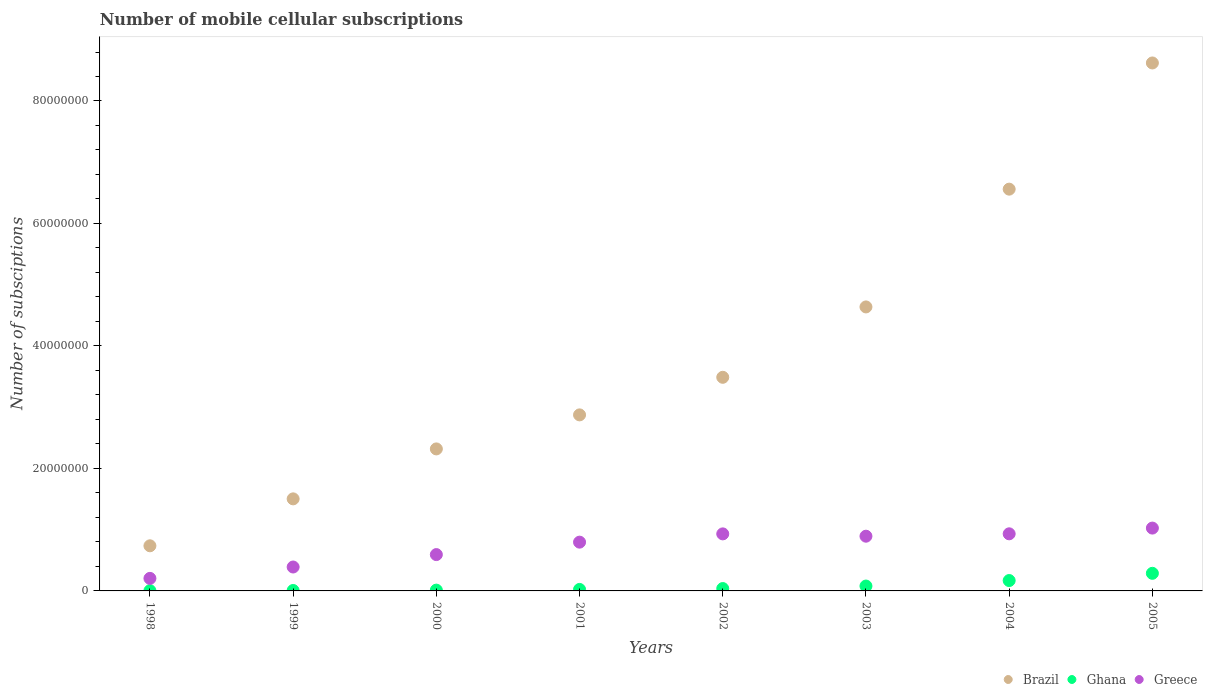Is the number of dotlines equal to the number of legend labels?
Provide a succinct answer. Yes. What is the number of mobile cellular subscriptions in Brazil in 1998?
Ensure brevity in your answer.  7.37e+06. Across all years, what is the maximum number of mobile cellular subscriptions in Brazil?
Your answer should be very brief. 8.62e+07. Across all years, what is the minimum number of mobile cellular subscriptions in Greece?
Your answer should be very brief. 2.05e+06. In which year was the number of mobile cellular subscriptions in Ghana maximum?
Offer a terse response. 2005. What is the total number of mobile cellular subscriptions in Greece in the graph?
Make the answer very short. 5.77e+07. What is the difference between the number of mobile cellular subscriptions in Ghana in 2002 and that in 2003?
Your response must be concise. -4.09e+05. What is the difference between the number of mobile cellular subscriptions in Greece in 2004 and the number of mobile cellular subscriptions in Brazil in 2002?
Your answer should be very brief. -2.56e+07. What is the average number of mobile cellular subscriptions in Brazil per year?
Ensure brevity in your answer.  3.84e+07. In the year 2001, what is the difference between the number of mobile cellular subscriptions in Ghana and number of mobile cellular subscriptions in Greece?
Your answer should be very brief. -7.72e+06. What is the ratio of the number of mobile cellular subscriptions in Ghana in 1999 to that in 2000?
Make the answer very short. 0.54. What is the difference between the highest and the second highest number of mobile cellular subscriptions in Ghana?
Ensure brevity in your answer.  1.18e+06. What is the difference between the highest and the lowest number of mobile cellular subscriptions in Brazil?
Keep it short and to the point. 7.88e+07. In how many years, is the number of mobile cellular subscriptions in Brazil greater than the average number of mobile cellular subscriptions in Brazil taken over all years?
Make the answer very short. 3. Is it the case that in every year, the sum of the number of mobile cellular subscriptions in Greece and number of mobile cellular subscriptions in Ghana  is greater than the number of mobile cellular subscriptions in Brazil?
Give a very brief answer. No. How many dotlines are there?
Make the answer very short. 3. How many years are there in the graph?
Provide a short and direct response. 8. What is the difference between two consecutive major ticks on the Y-axis?
Give a very brief answer. 2.00e+07. Are the values on the major ticks of Y-axis written in scientific E-notation?
Provide a short and direct response. No. Does the graph contain any zero values?
Your answer should be very brief. No. Where does the legend appear in the graph?
Offer a terse response. Bottom right. How many legend labels are there?
Keep it short and to the point. 3. How are the legend labels stacked?
Make the answer very short. Horizontal. What is the title of the graph?
Offer a terse response. Number of mobile cellular subscriptions. Does "Bulgaria" appear as one of the legend labels in the graph?
Offer a terse response. No. What is the label or title of the X-axis?
Offer a very short reply. Years. What is the label or title of the Y-axis?
Give a very brief answer. Number of subsciptions. What is the Number of subsciptions of Brazil in 1998?
Ensure brevity in your answer.  7.37e+06. What is the Number of subsciptions of Ghana in 1998?
Your response must be concise. 4.18e+04. What is the Number of subsciptions of Greece in 1998?
Your answer should be compact. 2.05e+06. What is the Number of subsciptions of Brazil in 1999?
Give a very brief answer. 1.50e+07. What is the Number of subsciptions in Ghana in 1999?
Your response must be concise. 7.00e+04. What is the Number of subsciptions in Greece in 1999?
Offer a very short reply. 3.90e+06. What is the Number of subsciptions in Brazil in 2000?
Provide a short and direct response. 2.32e+07. What is the Number of subsciptions in Ghana in 2000?
Offer a very short reply. 1.30e+05. What is the Number of subsciptions of Greece in 2000?
Make the answer very short. 5.93e+06. What is the Number of subsciptions in Brazil in 2001?
Your answer should be compact. 2.87e+07. What is the Number of subsciptions of Ghana in 2001?
Your answer should be compact. 2.44e+05. What is the Number of subsciptions in Greece in 2001?
Make the answer very short. 7.96e+06. What is the Number of subsciptions in Brazil in 2002?
Your answer should be compact. 3.49e+07. What is the Number of subsciptions of Ghana in 2002?
Your answer should be compact. 3.87e+05. What is the Number of subsciptions of Greece in 2002?
Provide a succinct answer. 9.31e+06. What is the Number of subsciptions of Brazil in 2003?
Your answer should be very brief. 4.64e+07. What is the Number of subsciptions in Ghana in 2003?
Give a very brief answer. 7.96e+05. What is the Number of subsciptions in Greece in 2003?
Make the answer very short. 8.94e+06. What is the Number of subsciptions in Brazil in 2004?
Give a very brief answer. 6.56e+07. What is the Number of subsciptions of Ghana in 2004?
Keep it short and to the point. 1.70e+06. What is the Number of subsciptions in Greece in 2004?
Make the answer very short. 9.32e+06. What is the Number of subsciptions of Brazil in 2005?
Keep it short and to the point. 8.62e+07. What is the Number of subsciptions of Ghana in 2005?
Give a very brief answer. 2.87e+06. What is the Number of subsciptions of Greece in 2005?
Keep it short and to the point. 1.03e+07. Across all years, what is the maximum Number of subsciptions in Brazil?
Your answer should be very brief. 8.62e+07. Across all years, what is the maximum Number of subsciptions in Ghana?
Your answer should be compact. 2.87e+06. Across all years, what is the maximum Number of subsciptions in Greece?
Make the answer very short. 1.03e+07. Across all years, what is the minimum Number of subsciptions of Brazil?
Your response must be concise. 7.37e+06. Across all years, what is the minimum Number of subsciptions in Ghana?
Keep it short and to the point. 4.18e+04. Across all years, what is the minimum Number of subsciptions of Greece?
Give a very brief answer. 2.05e+06. What is the total Number of subsciptions of Brazil in the graph?
Ensure brevity in your answer.  3.07e+08. What is the total Number of subsciptions in Ghana in the graph?
Your answer should be compact. 6.24e+06. What is the total Number of subsciptions of Greece in the graph?
Your answer should be very brief. 5.77e+07. What is the difference between the Number of subsciptions in Brazil in 1998 and that in 1999?
Keep it short and to the point. -7.66e+06. What is the difference between the Number of subsciptions of Ghana in 1998 and that in 1999?
Offer a terse response. -2.83e+04. What is the difference between the Number of subsciptions in Greece in 1998 and that in 1999?
Provide a succinct answer. -1.86e+06. What is the difference between the Number of subsciptions in Brazil in 1998 and that in 2000?
Ensure brevity in your answer.  -1.58e+07. What is the difference between the Number of subsciptions in Ghana in 1998 and that in 2000?
Keep it short and to the point. -8.83e+04. What is the difference between the Number of subsciptions in Greece in 1998 and that in 2000?
Your response must be concise. -3.89e+06. What is the difference between the Number of subsciptions in Brazil in 1998 and that in 2001?
Your response must be concise. -2.14e+07. What is the difference between the Number of subsciptions of Ghana in 1998 and that in 2001?
Offer a terse response. -2.02e+05. What is the difference between the Number of subsciptions in Greece in 1998 and that in 2001?
Your answer should be very brief. -5.92e+06. What is the difference between the Number of subsciptions in Brazil in 1998 and that in 2002?
Your response must be concise. -2.75e+07. What is the difference between the Number of subsciptions of Ghana in 1998 and that in 2002?
Your answer should be compact. -3.45e+05. What is the difference between the Number of subsciptions in Greece in 1998 and that in 2002?
Give a very brief answer. -7.27e+06. What is the difference between the Number of subsciptions in Brazil in 1998 and that in 2003?
Provide a succinct answer. -3.90e+07. What is the difference between the Number of subsciptions in Ghana in 1998 and that in 2003?
Offer a very short reply. -7.54e+05. What is the difference between the Number of subsciptions of Greece in 1998 and that in 2003?
Keep it short and to the point. -6.89e+06. What is the difference between the Number of subsciptions of Brazil in 1998 and that in 2004?
Provide a short and direct response. -5.82e+07. What is the difference between the Number of subsciptions in Ghana in 1998 and that in 2004?
Your answer should be very brief. -1.65e+06. What is the difference between the Number of subsciptions in Greece in 1998 and that in 2004?
Make the answer very short. -7.28e+06. What is the difference between the Number of subsciptions of Brazil in 1998 and that in 2005?
Make the answer very short. -7.88e+07. What is the difference between the Number of subsciptions of Ghana in 1998 and that in 2005?
Your answer should be very brief. -2.83e+06. What is the difference between the Number of subsciptions of Greece in 1998 and that in 2005?
Provide a succinct answer. -8.21e+06. What is the difference between the Number of subsciptions of Brazil in 1999 and that in 2000?
Ensure brevity in your answer.  -8.16e+06. What is the difference between the Number of subsciptions in Ghana in 1999 and that in 2000?
Provide a succinct answer. -6.00e+04. What is the difference between the Number of subsciptions of Greece in 1999 and that in 2000?
Ensure brevity in your answer.  -2.03e+06. What is the difference between the Number of subsciptions in Brazil in 1999 and that in 2001?
Your answer should be very brief. -1.37e+07. What is the difference between the Number of subsciptions in Ghana in 1999 and that in 2001?
Give a very brief answer. -1.74e+05. What is the difference between the Number of subsciptions in Greece in 1999 and that in 2001?
Make the answer very short. -4.06e+06. What is the difference between the Number of subsciptions of Brazil in 1999 and that in 2002?
Provide a succinct answer. -1.98e+07. What is the difference between the Number of subsciptions in Ghana in 1999 and that in 2002?
Your answer should be compact. -3.17e+05. What is the difference between the Number of subsciptions of Greece in 1999 and that in 2002?
Give a very brief answer. -5.41e+06. What is the difference between the Number of subsciptions of Brazil in 1999 and that in 2003?
Offer a very short reply. -3.13e+07. What is the difference between the Number of subsciptions of Ghana in 1999 and that in 2003?
Offer a very short reply. -7.26e+05. What is the difference between the Number of subsciptions in Greece in 1999 and that in 2003?
Give a very brief answer. -5.03e+06. What is the difference between the Number of subsciptions in Brazil in 1999 and that in 2004?
Your response must be concise. -5.06e+07. What is the difference between the Number of subsciptions of Ghana in 1999 and that in 2004?
Offer a very short reply. -1.62e+06. What is the difference between the Number of subsciptions in Greece in 1999 and that in 2004?
Provide a short and direct response. -5.42e+06. What is the difference between the Number of subsciptions in Brazil in 1999 and that in 2005?
Your answer should be compact. -7.12e+07. What is the difference between the Number of subsciptions of Ghana in 1999 and that in 2005?
Provide a short and direct response. -2.80e+06. What is the difference between the Number of subsciptions of Greece in 1999 and that in 2005?
Keep it short and to the point. -6.36e+06. What is the difference between the Number of subsciptions in Brazil in 2000 and that in 2001?
Ensure brevity in your answer.  -5.56e+06. What is the difference between the Number of subsciptions of Ghana in 2000 and that in 2001?
Ensure brevity in your answer.  -1.14e+05. What is the difference between the Number of subsciptions of Greece in 2000 and that in 2001?
Give a very brief answer. -2.03e+06. What is the difference between the Number of subsciptions in Brazil in 2000 and that in 2002?
Your answer should be compact. -1.17e+07. What is the difference between the Number of subsciptions of Ghana in 2000 and that in 2002?
Your response must be concise. -2.57e+05. What is the difference between the Number of subsciptions in Greece in 2000 and that in 2002?
Make the answer very short. -3.38e+06. What is the difference between the Number of subsciptions of Brazil in 2000 and that in 2003?
Give a very brief answer. -2.32e+07. What is the difference between the Number of subsciptions in Ghana in 2000 and that in 2003?
Provide a succinct answer. -6.65e+05. What is the difference between the Number of subsciptions of Greece in 2000 and that in 2003?
Make the answer very short. -3.00e+06. What is the difference between the Number of subsciptions of Brazil in 2000 and that in 2004?
Your answer should be compact. -4.24e+07. What is the difference between the Number of subsciptions of Ghana in 2000 and that in 2004?
Provide a succinct answer. -1.56e+06. What is the difference between the Number of subsciptions in Greece in 2000 and that in 2004?
Make the answer very short. -3.39e+06. What is the difference between the Number of subsciptions of Brazil in 2000 and that in 2005?
Provide a short and direct response. -6.30e+07. What is the difference between the Number of subsciptions of Ghana in 2000 and that in 2005?
Provide a succinct answer. -2.74e+06. What is the difference between the Number of subsciptions in Greece in 2000 and that in 2005?
Make the answer very short. -4.33e+06. What is the difference between the Number of subsciptions of Brazil in 2001 and that in 2002?
Provide a succinct answer. -6.14e+06. What is the difference between the Number of subsciptions of Ghana in 2001 and that in 2002?
Offer a very short reply. -1.43e+05. What is the difference between the Number of subsciptions in Greece in 2001 and that in 2002?
Provide a succinct answer. -1.35e+06. What is the difference between the Number of subsciptions of Brazil in 2001 and that in 2003?
Ensure brevity in your answer.  -1.76e+07. What is the difference between the Number of subsciptions of Ghana in 2001 and that in 2003?
Ensure brevity in your answer.  -5.52e+05. What is the difference between the Number of subsciptions in Greece in 2001 and that in 2003?
Give a very brief answer. -9.72e+05. What is the difference between the Number of subsciptions in Brazil in 2001 and that in 2004?
Give a very brief answer. -3.69e+07. What is the difference between the Number of subsciptions in Ghana in 2001 and that in 2004?
Provide a short and direct response. -1.45e+06. What is the difference between the Number of subsciptions in Greece in 2001 and that in 2004?
Your response must be concise. -1.36e+06. What is the difference between the Number of subsciptions of Brazil in 2001 and that in 2005?
Give a very brief answer. -5.75e+07. What is the difference between the Number of subsciptions in Ghana in 2001 and that in 2005?
Offer a very short reply. -2.63e+06. What is the difference between the Number of subsciptions of Greece in 2001 and that in 2005?
Your answer should be compact. -2.30e+06. What is the difference between the Number of subsciptions in Brazil in 2002 and that in 2003?
Make the answer very short. -1.15e+07. What is the difference between the Number of subsciptions of Ghana in 2002 and that in 2003?
Give a very brief answer. -4.09e+05. What is the difference between the Number of subsciptions of Greece in 2002 and that in 2003?
Make the answer very short. 3.78e+05. What is the difference between the Number of subsciptions in Brazil in 2002 and that in 2004?
Your response must be concise. -3.07e+07. What is the difference between the Number of subsciptions in Ghana in 2002 and that in 2004?
Offer a very short reply. -1.31e+06. What is the difference between the Number of subsciptions of Greece in 2002 and that in 2004?
Offer a terse response. -1.01e+04. What is the difference between the Number of subsciptions of Brazil in 2002 and that in 2005?
Provide a short and direct response. -5.13e+07. What is the difference between the Number of subsciptions of Ghana in 2002 and that in 2005?
Make the answer very short. -2.49e+06. What is the difference between the Number of subsciptions in Greece in 2002 and that in 2005?
Provide a short and direct response. -9.46e+05. What is the difference between the Number of subsciptions of Brazil in 2003 and that in 2004?
Make the answer very short. -1.92e+07. What is the difference between the Number of subsciptions in Ghana in 2003 and that in 2004?
Keep it short and to the point. -8.99e+05. What is the difference between the Number of subsciptions in Greece in 2003 and that in 2004?
Your answer should be compact. -3.88e+05. What is the difference between the Number of subsciptions in Brazil in 2003 and that in 2005?
Offer a very short reply. -3.98e+07. What is the difference between the Number of subsciptions of Ghana in 2003 and that in 2005?
Your answer should be compact. -2.08e+06. What is the difference between the Number of subsciptions of Greece in 2003 and that in 2005?
Provide a succinct answer. -1.32e+06. What is the difference between the Number of subsciptions of Brazil in 2004 and that in 2005?
Provide a succinct answer. -2.06e+07. What is the difference between the Number of subsciptions of Ghana in 2004 and that in 2005?
Keep it short and to the point. -1.18e+06. What is the difference between the Number of subsciptions of Greece in 2004 and that in 2005?
Your response must be concise. -9.36e+05. What is the difference between the Number of subsciptions in Brazil in 1998 and the Number of subsciptions in Ghana in 1999?
Give a very brief answer. 7.30e+06. What is the difference between the Number of subsciptions in Brazil in 1998 and the Number of subsciptions in Greece in 1999?
Your answer should be very brief. 3.46e+06. What is the difference between the Number of subsciptions of Ghana in 1998 and the Number of subsciptions of Greece in 1999?
Your answer should be compact. -3.86e+06. What is the difference between the Number of subsciptions in Brazil in 1998 and the Number of subsciptions in Ghana in 2000?
Make the answer very short. 7.24e+06. What is the difference between the Number of subsciptions in Brazil in 1998 and the Number of subsciptions in Greece in 2000?
Keep it short and to the point. 1.44e+06. What is the difference between the Number of subsciptions in Ghana in 1998 and the Number of subsciptions in Greece in 2000?
Keep it short and to the point. -5.89e+06. What is the difference between the Number of subsciptions of Brazil in 1998 and the Number of subsciptions of Ghana in 2001?
Provide a short and direct response. 7.12e+06. What is the difference between the Number of subsciptions of Brazil in 1998 and the Number of subsciptions of Greece in 2001?
Your answer should be very brief. -5.96e+05. What is the difference between the Number of subsciptions of Ghana in 1998 and the Number of subsciptions of Greece in 2001?
Your answer should be compact. -7.92e+06. What is the difference between the Number of subsciptions in Brazil in 1998 and the Number of subsciptions in Ghana in 2002?
Provide a short and direct response. 6.98e+06. What is the difference between the Number of subsciptions in Brazil in 1998 and the Number of subsciptions in Greece in 2002?
Make the answer very short. -1.95e+06. What is the difference between the Number of subsciptions of Ghana in 1998 and the Number of subsciptions of Greece in 2002?
Offer a terse response. -9.27e+06. What is the difference between the Number of subsciptions of Brazil in 1998 and the Number of subsciptions of Ghana in 2003?
Provide a succinct answer. 6.57e+06. What is the difference between the Number of subsciptions of Brazil in 1998 and the Number of subsciptions of Greece in 2003?
Provide a short and direct response. -1.57e+06. What is the difference between the Number of subsciptions of Ghana in 1998 and the Number of subsciptions of Greece in 2003?
Give a very brief answer. -8.89e+06. What is the difference between the Number of subsciptions of Brazil in 1998 and the Number of subsciptions of Ghana in 2004?
Offer a very short reply. 5.67e+06. What is the difference between the Number of subsciptions of Brazil in 1998 and the Number of subsciptions of Greece in 2004?
Provide a succinct answer. -1.96e+06. What is the difference between the Number of subsciptions in Ghana in 1998 and the Number of subsciptions in Greece in 2004?
Your response must be concise. -9.28e+06. What is the difference between the Number of subsciptions of Brazil in 1998 and the Number of subsciptions of Ghana in 2005?
Offer a terse response. 4.49e+06. What is the difference between the Number of subsciptions in Brazil in 1998 and the Number of subsciptions in Greece in 2005?
Offer a terse response. -2.89e+06. What is the difference between the Number of subsciptions in Ghana in 1998 and the Number of subsciptions in Greece in 2005?
Provide a short and direct response. -1.02e+07. What is the difference between the Number of subsciptions of Brazil in 1999 and the Number of subsciptions of Ghana in 2000?
Give a very brief answer. 1.49e+07. What is the difference between the Number of subsciptions in Brazil in 1999 and the Number of subsciptions in Greece in 2000?
Your answer should be compact. 9.10e+06. What is the difference between the Number of subsciptions in Ghana in 1999 and the Number of subsciptions in Greece in 2000?
Your answer should be very brief. -5.86e+06. What is the difference between the Number of subsciptions of Brazil in 1999 and the Number of subsciptions of Ghana in 2001?
Keep it short and to the point. 1.48e+07. What is the difference between the Number of subsciptions in Brazil in 1999 and the Number of subsciptions in Greece in 2001?
Ensure brevity in your answer.  7.07e+06. What is the difference between the Number of subsciptions of Ghana in 1999 and the Number of subsciptions of Greece in 2001?
Offer a terse response. -7.89e+06. What is the difference between the Number of subsciptions of Brazil in 1999 and the Number of subsciptions of Ghana in 2002?
Offer a terse response. 1.46e+07. What is the difference between the Number of subsciptions in Brazil in 1999 and the Number of subsciptions in Greece in 2002?
Ensure brevity in your answer.  5.72e+06. What is the difference between the Number of subsciptions of Ghana in 1999 and the Number of subsciptions of Greece in 2002?
Keep it short and to the point. -9.24e+06. What is the difference between the Number of subsciptions in Brazil in 1999 and the Number of subsciptions in Ghana in 2003?
Your response must be concise. 1.42e+07. What is the difference between the Number of subsciptions in Brazil in 1999 and the Number of subsciptions in Greece in 2003?
Provide a succinct answer. 6.10e+06. What is the difference between the Number of subsciptions of Ghana in 1999 and the Number of subsciptions of Greece in 2003?
Ensure brevity in your answer.  -8.87e+06. What is the difference between the Number of subsciptions in Brazil in 1999 and the Number of subsciptions in Ghana in 2004?
Your answer should be compact. 1.33e+07. What is the difference between the Number of subsciptions in Brazil in 1999 and the Number of subsciptions in Greece in 2004?
Keep it short and to the point. 5.71e+06. What is the difference between the Number of subsciptions in Ghana in 1999 and the Number of subsciptions in Greece in 2004?
Your answer should be very brief. -9.25e+06. What is the difference between the Number of subsciptions in Brazil in 1999 and the Number of subsciptions in Ghana in 2005?
Offer a terse response. 1.22e+07. What is the difference between the Number of subsciptions in Brazil in 1999 and the Number of subsciptions in Greece in 2005?
Offer a terse response. 4.77e+06. What is the difference between the Number of subsciptions in Ghana in 1999 and the Number of subsciptions in Greece in 2005?
Your answer should be very brief. -1.02e+07. What is the difference between the Number of subsciptions in Brazil in 2000 and the Number of subsciptions in Ghana in 2001?
Ensure brevity in your answer.  2.29e+07. What is the difference between the Number of subsciptions in Brazil in 2000 and the Number of subsciptions in Greece in 2001?
Ensure brevity in your answer.  1.52e+07. What is the difference between the Number of subsciptions of Ghana in 2000 and the Number of subsciptions of Greece in 2001?
Offer a very short reply. -7.83e+06. What is the difference between the Number of subsciptions of Brazil in 2000 and the Number of subsciptions of Ghana in 2002?
Provide a succinct answer. 2.28e+07. What is the difference between the Number of subsciptions in Brazil in 2000 and the Number of subsciptions in Greece in 2002?
Ensure brevity in your answer.  1.39e+07. What is the difference between the Number of subsciptions of Ghana in 2000 and the Number of subsciptions of Greece in 2002?
Provide a short and direct response. -9.18e+06. What is the difference between the Number of subsciptions of Brazil in 2000 and the Number of subsciptions of Ghana in 2003?
Keep it short and to the point. 2.24e+07. What is the difference between the Number of subsciptions of Brazil in 2000 and the Number of subsciptions of Greece in 2003?
Keep it short and to the point. 1.43e+07. What is the difference between the Number of subsciptions of Ghana in 2000 and the Number of subsciptions of Greece in 2003?
Your answer should be very brief. -8.81e+06. What is the difference between the Number of subsciptions in Brazil in 2000 and the Number of subsciptions in Ghana in 2004?
Your response must be concise. 2.15e+07. What is the difference between the Number of subsciptions of Brazil in 2000 and the Number of subsciptions of Greece in 2004?
Keep it short and to the point. 1.39e+07. What is the difference between the Number of subsciptions in Ghana in 2000 and the Number of subsciptions in Greece in 2004?
Your answer should be compact. -9.19e+06. What is the difference between the Number of subsciptions of Brazil in 2000 and the Number of subsciptions of Ghana in 2005?
Your response must be concise. 2.03e+07. What is the difference between the Number of subsciptions of Brazil in 2000 and the Number of subsciptions of Greece in 2005?
Your response must be concise. 1.29e+07. What is the difference between the Number of subsciptions in Ghana in 2000 and the Number of subsciptions in Greece in 2005?
Your answer should be very brief. -1.01e+07. What is the difference between the Number of subsciptions of Brazil in 2001 and the Number of subsciptions of Ghana in 2002?
Make the answer very short. 2.84e+07. What is the difference between the Number of subsciptions of Brazil in 2001 and the Number of subsciptions of Greece in 2002?
Provide a short and direct response. 1.94e+07. What is the difference between the Number of subsciptions of Ghana in 2001 and the Number of subsciptions of Greece in 2002?
Your answer should be compact. -9.07e+06. What is the difference between the Number of subsciptions in Brazil in 2001 and the Number of subsciptions in Ghana in 2003?
Your answer should be very brief. 2.80e+07. What is the difference between the Number of subsciptions of Brazil in 2001 and the Number of subsciptions of Greece in 2003?
Offer a terse response. 1.98e+07. What is the difference between the Number of subsciptions of Ghana in 2001 and the Number of subsciptions of Greece in 2003?
Offer a very short reply. -8.69e+06. What is the difference between the Number of subsciptions of Brazil in 2001 and the Number of subsciptions of Ghana in 2004?
Provide a succinct answer. 2.71e+07. What is the difference between the Number of subsciptions of Brazil in 2001 and the Number of subsciptions of Greece in 2004?
Offer a terse response. 1.94e+07. What is the difference between the Number of subsciptions in Ghana in 2001 and the Number of subsciptions in Greece in 2004?
Your response must be concise. -9.08e+06. What is the difference between the Number of subsciptions of Brazil in 2001 and the Number of subsciptions of Ghana in 2005?
Ensure brevity in your answer.  2.59e+07. What is the difference between the Number of subsciptions in Brazil in 2001 and the Number of subsciptions in Greece in 2005?
Provide a succinct answer. 1.85e+07. What is the difference between the Number of subsciptions of Ghana in 2001 and the Number of subsciptions of Greece in 2005?
Give a very brief answer. -1.00e+07. What is the difference between the Number of subsciptions in Brazil in 2002 and the Number of subsciptions in Ghana in 2003?
Ensure brevity in your answer.  3.41e+07. What is the difference between the Number of subsciptions in Brazil in 2002 and the Number of subsciptions in Greece in 2003?
Provide a short and direct response. 2.59e+07. What is the difference between the Number of subsciptions of Ghana in 2002 and the Number of subsciptions of Greece in 2003?
Offer a terse response. -8.55e+06. What is the difference between the Number of subsciptions in Brazil in 2002 and the Number of subsciptions in Ghana in 2004?
Ensure brevity in your answer.  3.32e+07. What is the difference between the Number of subsciptions of Brazil in 2002 and the Number of subsciptions of Greece in 2004?
Provide a succinct answer. 2.56e+07. What is the difference between the Number of subsciptions of Ghana in 2002 and the Number of subsciptions of Greece in 2004?
Give a very brief answer. -8.94e+06. What is the difference between the Number of subsciptions in Brazil in 2002 and the Number of subsciptions in Ghana in 2005?
Ensure brevity in your answer.  3.20e+07. What is the difference between the Number of subsciptions in Brazil in 2002 and the Number of subsciptions in Greece in 2005?
Offer a terse response. 2.46e+07. What is the difference between the Number of subsciptions in Ghana in 2002 and the Number of subsciptions in Greece in 2005?
Your answer should be very brief. -9.87e+06. What is the difference between the Number of subsciptions in Brazil in 2003 and the Number of subsciptions in Ghana in 2004?
Provide a succinct answer. 4.47e+07. What is the difference between the Number of subsciptions of Brazil in 2003 and the Number of subsciptions of Greece in 2004?
Ensure brevity in your answer.  3.70e+07. What is the difference between the Number of subsciptions of Ghana in 2003 and the Number of subsciptions of Greece in 2004?
Provide a succinct answer. -8.53e+06. What is the difference between the Number of subsciptions in Brazil in 2003 and the Number of subsciptions in Ghana in 2005?
Ensure brevity in your answer.  4.35e+07. What is the difference between the Number of subsciptions in Brazil in 2003 and the Number of subsciptions in Greece in 2005?
Provide a succinct answer. 3.61e+07. What is the difference between the Number of subsciptions of Ghana in 2003 and the Number of subsciptions of Greece in 2005?
Offer a very short reply. -9.46e+06. What is the difference between the Number of subsciptions of Brazil in 2004 and the Number of subsciptions of Ghana in 2005?
Give a very brief answer. 6.27e+07. What is the difference between the Number of subsciptions in Brazil in 2004 and the Number of subsciptions in Greece in 2005?
Your response must be concise. 5.53e+07. What is the difference between the Number of subsciptions of Ghana in 2004 and the Number of subsciptions of Greece in 2005?
Your answer should be very brief. -8.57e+06. What is the average Number of subsciptions of Brazil per year?
Offer a terse response. 3.84e+07. What is the average Number of subsciptions of Ghana per year?
Your answer should be very brief. 7.80e+05. What is the average Number of subsciptions in Greece per year?
Offer a very short reply. 7.21e+06. In the year 1998, what is the difference between the Number of subsciptions of Brazil and Number of subsciptions of Ghana?
Your answer should be very brief. 7.33e+06. In the year 1998, what is the difference between the Number of subsciptions in Brazil and Number of subsciptions in Greece?
Offer a terse response. 5.32e+06. In the year 1998, what is the difference between the Number of subsciptions in Ghana and Number of subsciptions in Greece?
Your answer should be very brief. -2.01e+06. In the year 1999, what is the difference between the Number of subsciptions in Brazil and Number of subsciptions in Ghana?
Your answer should be compact. 1.50e+07. In the year 1999, what is the difference between the Number of subsciptions of Brazil and Number of subsciptions of Greece?
Your response must be concise. 1.11e+07. In the year 1999, what is the difference between the Number of subsciptions in Ghana and Number of subsciptions in Greece?
Make the answer very short. -3.83e+06. In the year 2000, what is the difference between the Number of subsciptions of Brazil and Number of subsciptions of Ghana?
Your answer should be compact. 2.31e+07. In the year 2000, what is the difference between the Number of subsciptions of Brazil and Number of subsciptions of Greece?
Ensure brevity in your answer.  1.73e+07. In the year 2000, what is the difference between the Number of subsciptions in Ghana and Number of subsciptions in Greece?
Ensure brevity in your answer.  -5.80e+06. In the year 2001, what is the difference between the Number of subsciptions in Brazil and Number of subsciptions in Ghana?
Provide a succinct answer. 2.85e+07. In the year 2001, what is the difference between the Number of subsciptions in Brazil and Number of subsciptions in Greece?
Keep it short and to the point. 2.08e+07. In the year 2001, what is the difference between the Number of subsciptions in Ghana and Number of subsciptions in Greece?
Offer a very short reply. -7.72e+06. In the year 2002, what is the difference between the Number of subsciptions in Brazil and Number of subsciptions in Ghana?
Your response must be concise. 3.45e+07. In the year 2002, what is the difference between the Number of subsciptions in Brazil and Number of subsciptions in Greece?
Offer a terse response. 2.56e+07. In the year 2002, what is the difference between the Number of subsciptions of Ghana and Number of subsciptions of Greece?
Provide a succinct answer. -8.93e+06. In the year 2003, what is the difference between the Number of subsciptions of Brazil and Number of subsciptions of Ghana?
Provide a short and direct response. 4.56e+07. In the year 2003, what is the difference between the Number of subsciptions in Brazil and Number of subsciptions in Greece?
Your response must be concise. 3.74e+07. In the year 2003, what is the difference between the Number of subsciptions of Ghana and Number of subsciptions of Greece?
Your answer should be very brief. -8.14e+06. In the year 2004, what is the difference between the Number of subsciptions in Brazil and Number of subsciptions in Ghana?
Your answer should be very brief. 6.39e+07. In the year 2004, what is the difference between the Number of subsciptions in Brazil and Number of subsciptions in Greece?
Your answer should be compact. 5.63e+07. In the year 2004, what is the difference between the Number of subsciptions of Ghana and Number of subsciptions of Greece?
Your answer should be very brief. -7.63e+06. In the year 2005, what is the difference between the Number of subsciptions of Brazil and Number of subsciptions of Ghana?
Your response must be concise. 8.33e+07. In the year 2005, what is the difference between the Number of subsciptions in Brazil and Number of subsciptions in Greece?
Your answer should be very brief. 7.59e+07. In the year 2005, what is the difference between the Number of subsciptions of Ghana and Number of subsciptions of Greece?
Give a very brief answer. -7.39e+06. What is the ratio of the Number of subsciptions of Brazil in 1998 to that in 1999?
Provide a succinct answer. 0.49. What is the ratio of the Number of subsciptions of Ghana in 1998 to that in 1999?
Provide a short and direct response. 0.6. What is the ratio of the Number of subsciptions of Greece in 1998 to that in 1999?
Ensure brevity in your answer.  0.52. What is the ratio of the Number of subsciptions in Brazil in 1998 to that in 2000?
Give a very brief answer. 0.32. What is the ratio of the Number of subsciptions of Ghana in 1998 to that in 2000?
Offer a very short reply. 0.32. What is the ratio of the Number of subsciptions of Greece in 1998 to that in 2000?
Your answer should be very brief. 0.35. What is the ratio of the Number of subsciptions of Brazil in 1998 to that in 2001?
Make the answer very short. 0.26. What is the ratio of the Number of subsciptions in Ghana in 1998 to that in 2001?
Provide a short and direct response. 0.17. What is the ratio of the Number of subsciptions of Greece in 1998 to that in 2001?
Give a very brief answer. 0.26. What is the ratio of the Number of subsciptions of Brazil in 1998 to that in 2002?
Offer a very short reply. 0.21. What is the ratio of the Number of subsciptions of Ghana in 1998 to that in 2002?
Your answer should be very brief. 0.11. What is the ratio of the Number of subsciptions in Greece in 1998 to that in 2002?
Make the answer very short. 0.22. What is the ratio of the Number of subsciptions of Brazil in 1998 to that in 2003?
Your response must be concise. 0.16. What is the ratio of the Number of subsciptions of Ghana in 1998 to that in 2003?
Make the answer very short. 0.05. What is the ratio of the Number of subsciptions in Greece in 1998 to that in 2003?
Your answer should be very brief. 0.23. What is the ratio of the Number of subsciptions in Brazil in 1998 to that in 2004?
Offer a very short reply. 0.11. What is the ratio of the Number of subsciptions of Ghana in 1998 to that in 2004?
Keep it short and to the point. 0.02. What is the ratio of the Number of subsciptions of Greece in 1998 to that in 2004?
Your answer should be compact. 0.22. What is the ratio of the Number of subsciptions of Brazil in 1998 to that in 2005?
Provide a succinct answer. 0.09. What is the ratio of the Number of subsciptions of Ghana in 1998 to that in 2005?
Your answer should be compact. 0.01. What is the ratio of the Number of subsciptions of Greece in 1998 to that in 2005?
Your answer should be very brief. 0.2. What is the ratio of the Number of subsciptions in Brazil in 1999 to that in 2000?
Your response must be concise. 0.65. What is the ratio of the Number of subsciptions in Ghana in 1999 to that in 2000?
Your answer should be compact. 0.54. What is the ratio of the Number of subsciptions in Greece in 1999 to that in 2000?
Offer a very short reply. 0.66. What is the ratio of the Number of subsciptions in Brazil in 1999 to that in 2001?
Your answer should be compact. 0.52. What is the ratio of the Number of subsciptions in Ghana in 1999 to that in 2001?
Your answer should be very brief. 0.29. What is the ratio of the Number of subsciptions of Greece in 1999 to that in 2001?
Provide a succinct answer. 0.49. What is the ratio of the Number of subsciptions of Brazil in 1999 to that in 2002?
Offer a very short reply. 0.43. What is the ratio of the Number of subsciptions in Ghana in 1999 to that in 2002?
Keep it short and to the point. 0.18. What is the ratio of the Number of subsciptions of Greece in 1999 to that in 2002?
Offer a very short reply. 0.42. What is the ratio of the Number of subsciptions of Brazil in 1999 to that in 2003?
Offer a very short reply. 0.32. What is the ratio of the Number of subsciptions in Ghana in 1999 to that in 2003?
Give a very brief answer. 0.09. What is the ratio of the Number of subsciptions of Greece in 1999 to that in 2003?
Your answer should be compact. 0.44. What is the ratio of the Number of subsciptions in Brazil in 1999 to that in 2004?
Your response must be concise. 0.23. What is the ratio of the Number of subsciptions in Ghana in 1999 to that in 2004?
Ensure brevity in your answer.  0.04. What is the ratio of the Number of subsciptions of Greece in 1999 to that in 2004?
Your answer should be compact. 0.42. What is the ratio of the Number of subsciptions of Brazil in 1999 to that in 2005?
Provide a succinct answer. 0.17. What is the ratio of the Number of subsciptions in Ghana in 1999 to that in 2005?
Your response must be concise. 0.02. What is the ratio of the Number of subsciptions of Greece in 1999 to that in 2005?
Make the answer very short. 0.38. What is the ratio of the Number of subsciptions of Brazil in 2000 to that in 2001?
Keep it short and to the point. 0.81. What is the ratio of the Number of subsciptions of Ghana in 2000 to that in 2001?
Offer a very short reply. 0.53. What is the ratio of the Number of subsciptions of Greece in 2000 to that in 2001?
Keep it short and to the point. 0.74. What is the ratio of the Number of subsciptions in Brazil in 2000 to that in 2002?
Ensure brevity in your answer.  0.66. What is the ratio of the Number of subsciptions of Ghana in 2000 to that in 2002?
Your answer should be very brief. 0.34. What is the ratio of the Number of subsciptions of Greece in 2000 to that in 2002?
Give a very brief answer. 0.64. What is the ratio of the Number of subsciptions in Brazil in 2000 to that in 2003?
Offer a terse response. 0.5. What is the ratio of the Number of subsciptions in Ghana in 2000 to that in 2003?
Offer a very short reply. 0.16. What is the ratio of the Number of subsciptions in Greece in 2000 to that in 2003?
Offer a very short reply. 0.66. What is the ratio of the Number of subsciptions of Brazil in 2000 to that in 2004?
Keep it short and to the point. 0.35. What is the ratio of the Number of subsciptions in Ghana in 2000 to that in 2004?
Provide a succinct answer. 0.08. What is the ratio of the Number of subsciptions of Greece in 2000 to that in 2004?
Your answer should be very brief. 0.64. What is the ratio of the Number of subsciptions of Brazil in 2000 to that in 2005?
Provide a succinct answer. 0.27. What is the ratio of the Number of subsciptions in Ghana in 2000 to that in 2005?
Keep it short and to the point. 0.05. What is the ratio of the Number of subsciptions in Greece in 2000 to that in 2005?
Your answer should be very brief. 0.58. What is the ratio of the Number of subsciptions in Brazil in 2001 to that in 2002?
Provide a succinct answer. 0.82. What is the ratio of the Number of subsciptions of Ghana in 2001 to that in 2002?
Keep it short and to the point. 0.63. What is the ratio of the Number of subsciptions of Greece in 2001 to that in 2002?
Make the answer very short. 0.85. What is the ratio of the Number of subsciptions of Brazil in 2001 to that in 2003?
Make the answer very short. 0.62. What is the ratio of the Number of subsciptions of Ghana in 2001 to that in 2003?
Your response must be concise. 0.31. What is the ratio of the Number of subsciptions of Greece in 2001 to that in 2003?
Offer a terse response. 0.89. What is the ratio of the Number of subsciptions in Brazil in 2001 to that in 2004?
Provide a succinct answer. 0.44. What is the ratio of the Number of subsciptions in Ghana in 2001 to that in 2004?
Your answer should be very brief. 0.14. What is the ratio of the Number of subsciptions of Greece in 2001 to that in 2004?
Keep it short and to the point. 0.85. What is the ratio of the Number of subsciptions in Brazil in 2001 to that in 2005?
Your answer should be compact. 0.33. What is the ratio of the Number of subsciptions in Ghana in 2001 to that in 2005?
Ensure brevity in your answer.  0.08. What is the ratio of the Number of subsciptions of Greece in 2001 to that in 2005?
Your answer should be very brief. 0.78. What is the ratio of the Number of subsciptions of Brazil in 2002 to that in 2003?
Offer a terse response. 0.75. What is the ratio of the Number of subsciptions of Ghana in 2002 to that in 2003?
Your response must be concise. 0.49. What is the ratio of the Number of subsciptions in Greece in 2002 to that in 2003?
Offer a very short reply. 1.04. What is the ratio of the Number of subsciptions in Brazil in 2002 to that in 2004?
Give a very brief answer. 0.53. What is the ratio of the Number of subsciptions in Ghana in 2002 to that in 2004?
Provide a succinct answer. 0.23. What is the ratio of the Number of subsciptions of Greece in 2002 to that in 2004?
Give a very brief answer. 1. What is the ratio of the Number of subsciptions of Brazil in 2002 to that in 2005?
Keep it short and to the point. 0.4. What is the ratio of the Number of subsciptions of Ghana in 2002 to that in 2005?
Keep it short and to the point. 0.13. What is the ratio of the Number of subsciptions in Greece in 2002 to that in 2005?
Give a very brief answer. 0.91. What is the ratio of the Number of subsciptions of Brazil in 2003 to that in 2004?
Your answer should be compact. 0.71. What is the ratio of the Number of subsciptions in Ghana in 2003 to that in 2004?
Keep it short and to the point. 0.47. What is the ratio of the Number of subsciptions in Greece in 2003 to that in 2004?
Make the answer very short. 0.96. What is the ratio of the Number of subsciptions in Brazil in 2003 to that in 2005?
Ensure brevity in your answer.  0.54. What is the ratio of the Number of subsciptions of Ghana in 2003 to that in 2005?
Your response must be concise. 0.28. What is the ratio of the Number of subsciptions of Greece in 2003 to that in 2005?
Offer a very short reply. 0.87. What is the ratio of the Number of subsciptions in Brazil in 2004 to that in 2005?
Your answer should be compact. 0.76. What is the ratio of the Number of subsciptions of Ghana in 2004 to that in 2005?
Make the answer very short. 0.59. What is the ratio of the Number of subsciptions in Greece in 2004 to that in 2005?
Give a very brief answer. 0.91. What is the difference between the highest and the second highest Number of subsciptions of Brazil?
Your response must be concise. 2.06e+07. What is the difference between the highest and the second highest Number of subsciptions of Ghana?
Your response must be concise. 1.18e+06. What is the difference between the highest and the second highest Number of subsciptions of Greece?
Give a very brief answer. 9.36e+05. What is the difference between the highest and the lowest Number of subsciptions in Brazil?
Your answer should be very brief. 7.88e+07. What is the difference between the highest and the lowest Number of subsciptions in Ghana?
Keep it short and to the point. 2.83e+06. What is the difference between the highest and the lowest Number of subsciptions of Greece?
Offer a very short reply. 8.21e+06. 